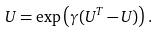Convert formula to latex. <formula><loc_0><loc_0><loc_500><loc_500>U = \exp \left ( \gamma ( U ^ { T } - U ) \right ) .</formula> 